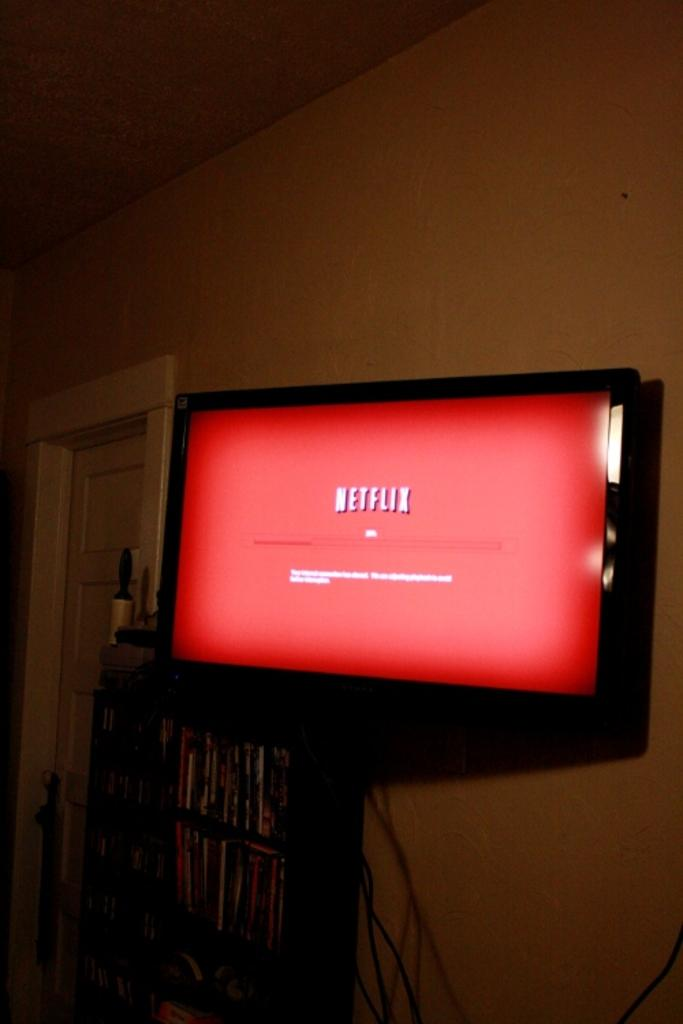<image>
Create a compact narrative representing the image presented. A black tv mounted to a wall with the Netflix app opening 